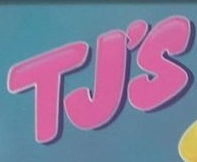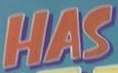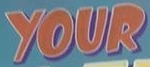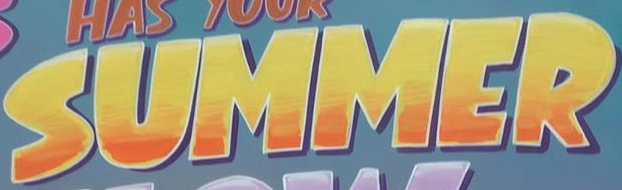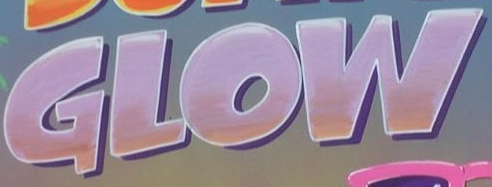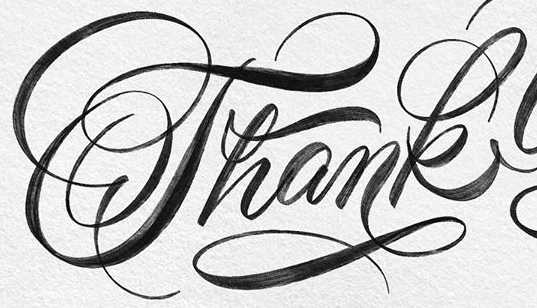What text is displayed in these images sequentially, separated by a semicolon? TJ'S; HAS; YOUR; SUMMER; GLOW; Thank 